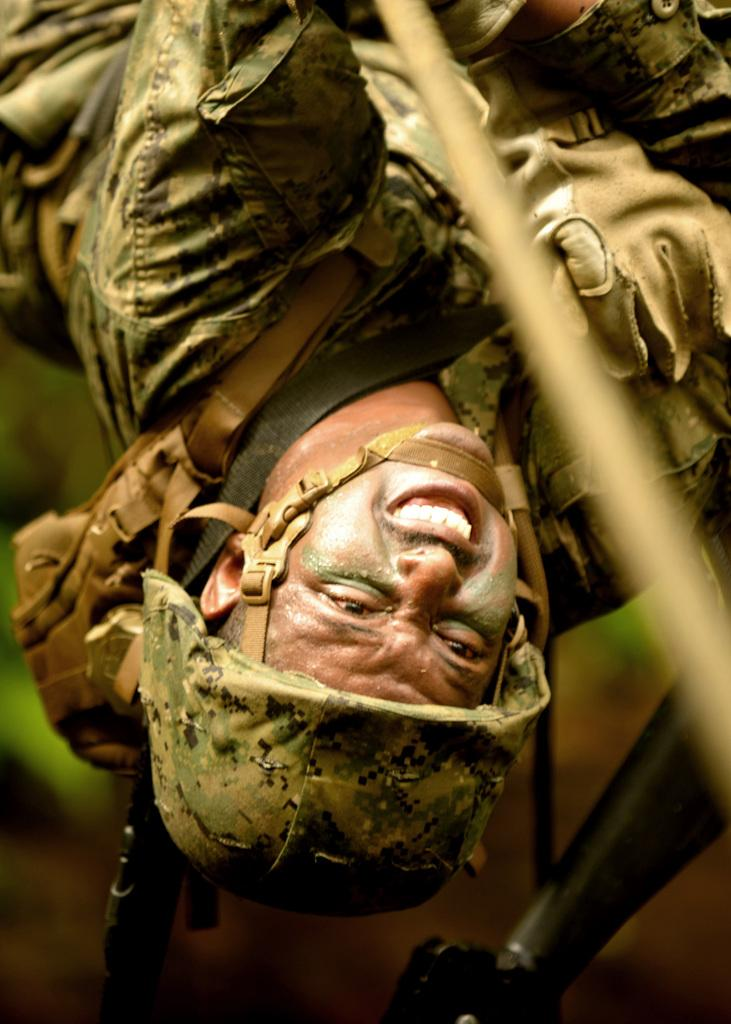What type of headgear is the man wearing in the image? The man is wearing a helmet in the image. What type of clothing is the man wearing in the image? The man is wearing military dress in the image. What type of hand protection is the man wearing in the image? The man is wearing gloves in the image. Can you describe the background of the image? The background of the image is blurry. What type of berry is the man eating in the image? There is no berry present in the image, and the man is not eating anything. How does the man's digestion process appear in the image? There is no indication of the man's digestion process in the image. 